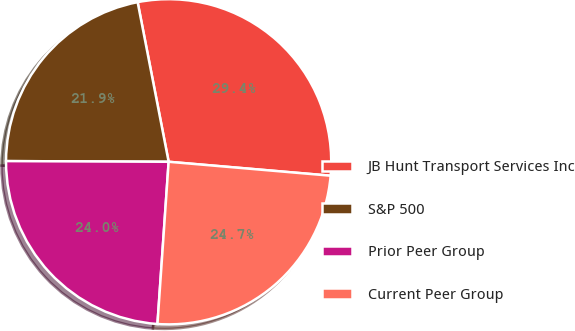<chart> <loc_0><loc_0><loc_500><loc_500><pie_chart><fcel>JB Hunt Transport Services Inc<fcel>S&P 500<fcel>Prior Peer Group<fcel>Current Peer Group<nl><fcel>29.42%<fcel>21.88%<fcel>23.97%<fcel>24.73%<nl></chart> 